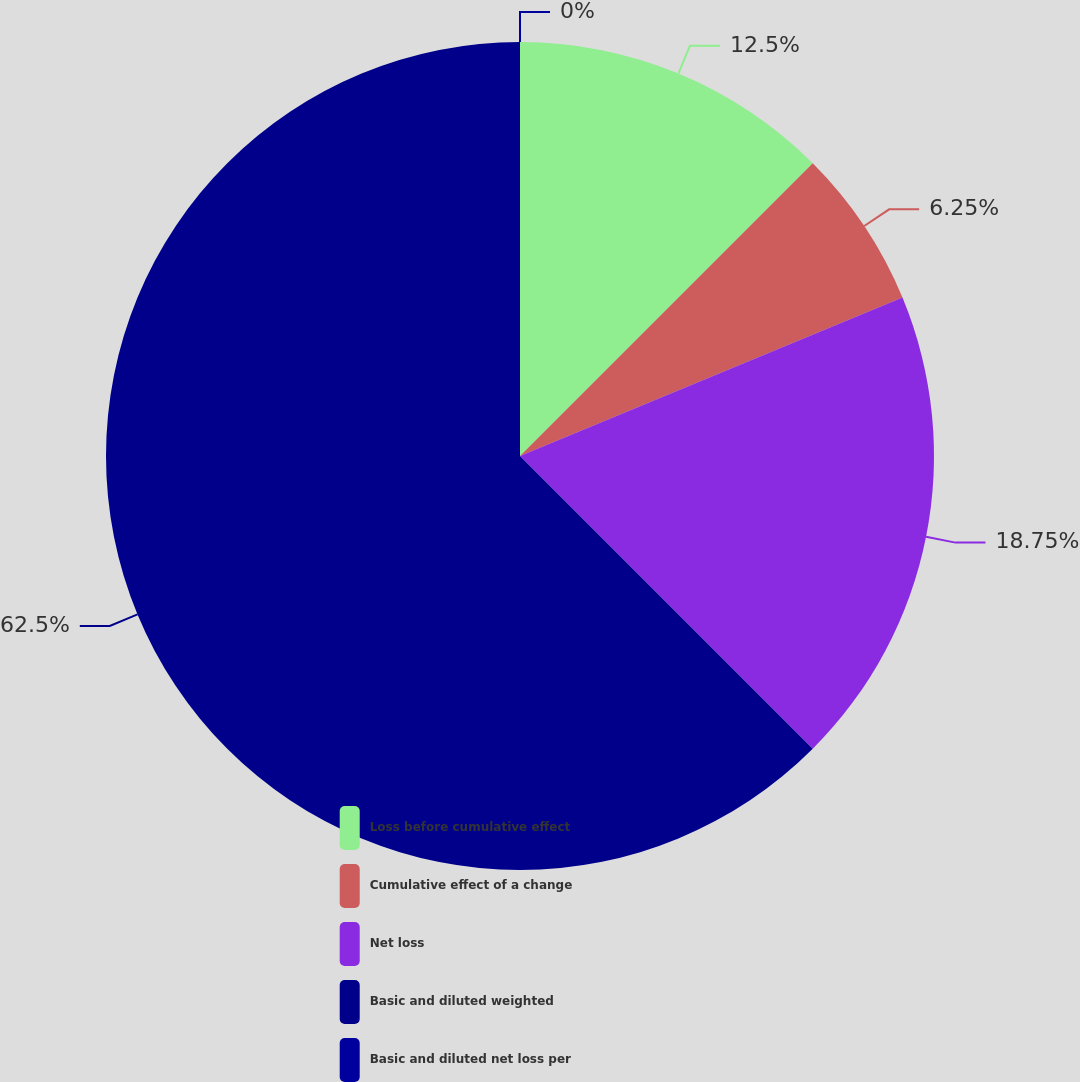<chart> <loc_0><loc_0><loc_500><loc_500><pie_chart><fcel>Loss before cumulative effect<fcel>Cumulative effect of a change<fcel>Net loss<fcel>Basic and diluted weighted<fcel>Basic and diluted net loss per<nl><fcel>12.5%<fcel>6.25%<fcel>18.75%<fcel>62.5%<fcel>0.0%<nl></chart> 